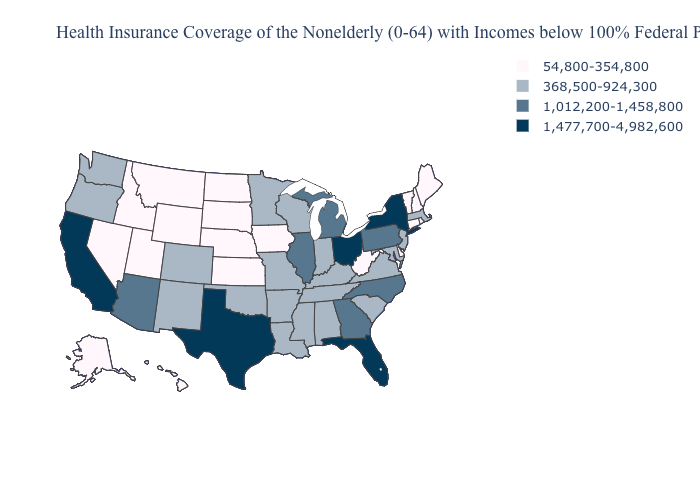What is the value of Iowa?
Write a very short answer. 54,800-354,800. How many symbols are there in the legend?
Short answer required. 4. Does Delaware have the lowest value in the South?
Be succinct. Yes. Among the states that border Texas , which have the lowest value?
Quick response, please. Arkansas, Louisiana, New Mexico, Oklahoma. Among the states that border Mississippi , which have the lowest value?
Short answer required. Alabama, Arkansas, Louisiana, Tennessee. What is the value of Nevada?
Short answer required. 54,800-354,800. How many symbols are there in the legend?
Give a very brief answer. 4. Does Colorado have a higher value than Wyoming?
Concise answer only. Yes. Among the states that border Illinois , does Indiana have the lowest value?
Quick response, please. No. Name the states that have a value in the range 368,500-924,300?
Answer briefly. Alabama, Arkansas, Colorado, Indiana, Kentucky, Louisiana, Maryland, Massachusetts, Minnesota, Mississippi, Missouri, New Jersey, New Mexico, Oklahoma, Oregon, South Carolina, Tennessee, Virginia, Washington, Wisconsin. Does Mississippi have the highest value in the South?
Short answer required. No. Which states have the lowest value in the USA?
Write a very short answer. Alaska, Connecticut, Delaware, Hawaii, Idaho, Iowa, Kansas, Maine, Montana, Nebraska, Nevada, New Hampshire, North Dakota, Rhode Island, South Dakota, Utah, Vermont, West Virginia, Wyoming. Which states have the lowest value in the Northeast?
Answer briefly. Connecticut, Maine, New Hampshire, Rhode Island, Vermont. Name the states that have a value in the range 368,500-924,300?
Keep it brief. Alabama, Arkansas, Colorado, Indiana, Kentucky, Louisiana, Maryland, Massachusetts, Minnesota, Mississippi, Missouri, New Jersey, New Mexico, Oklahoma, Oregon, South Carolina, Tennessee, Virginia, Washington, Wisconsin. What is the value of Minnesota?
Give a very brief answer. 368,500-924,300. 